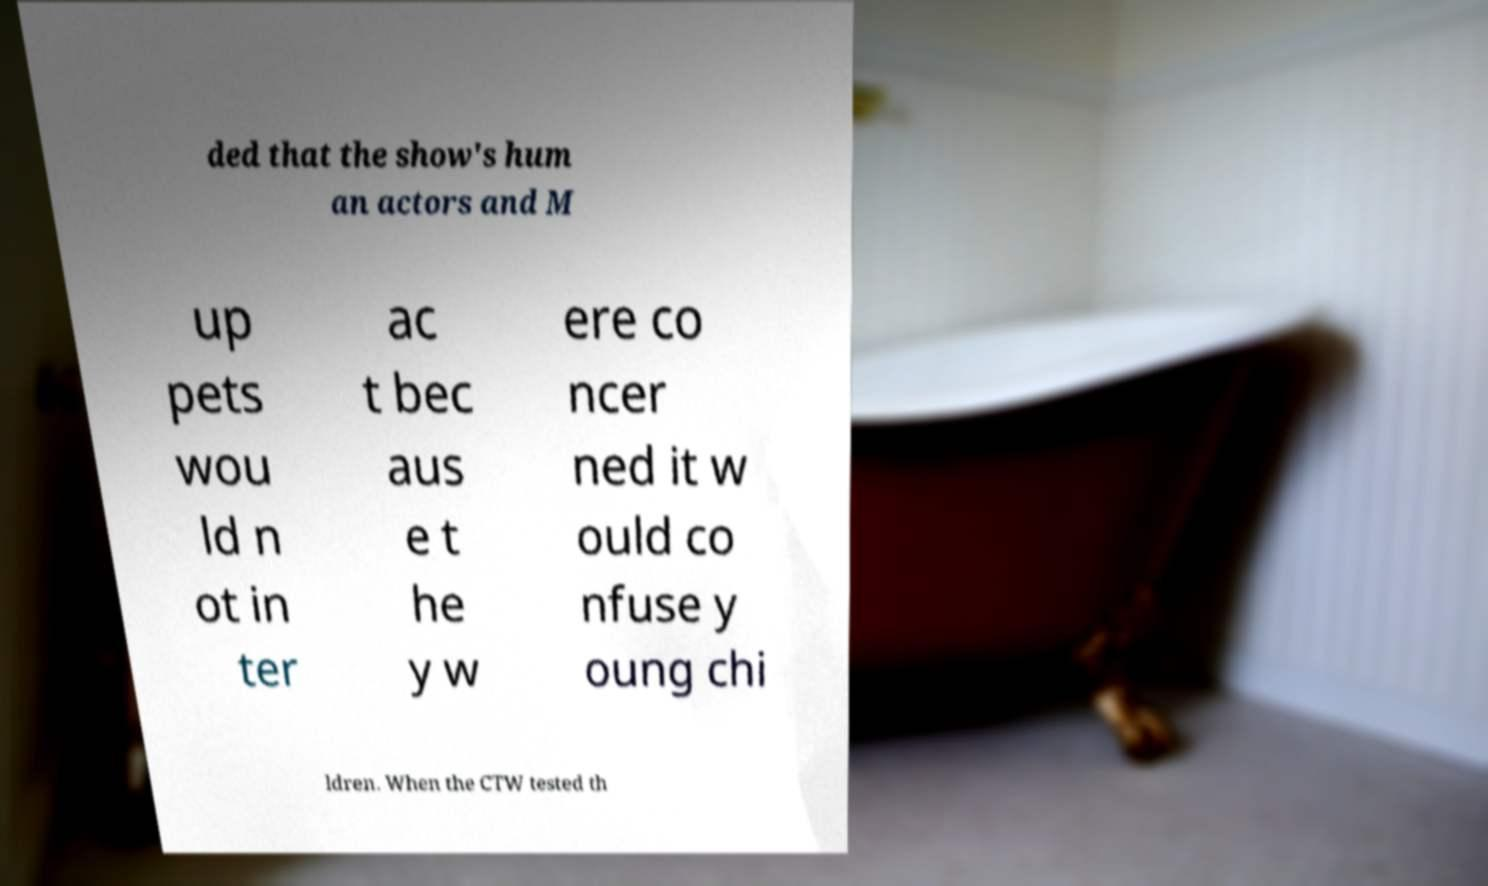For documentation purposes, I need the text within this image transcribed. Could you provide that? ded that the show's hum an actors and M up pets wou ld n ot in ter ac t bec aus e t he y w ere co ncer ned it w ould co nfuse y oung chi ldren. When the CTW tested th 